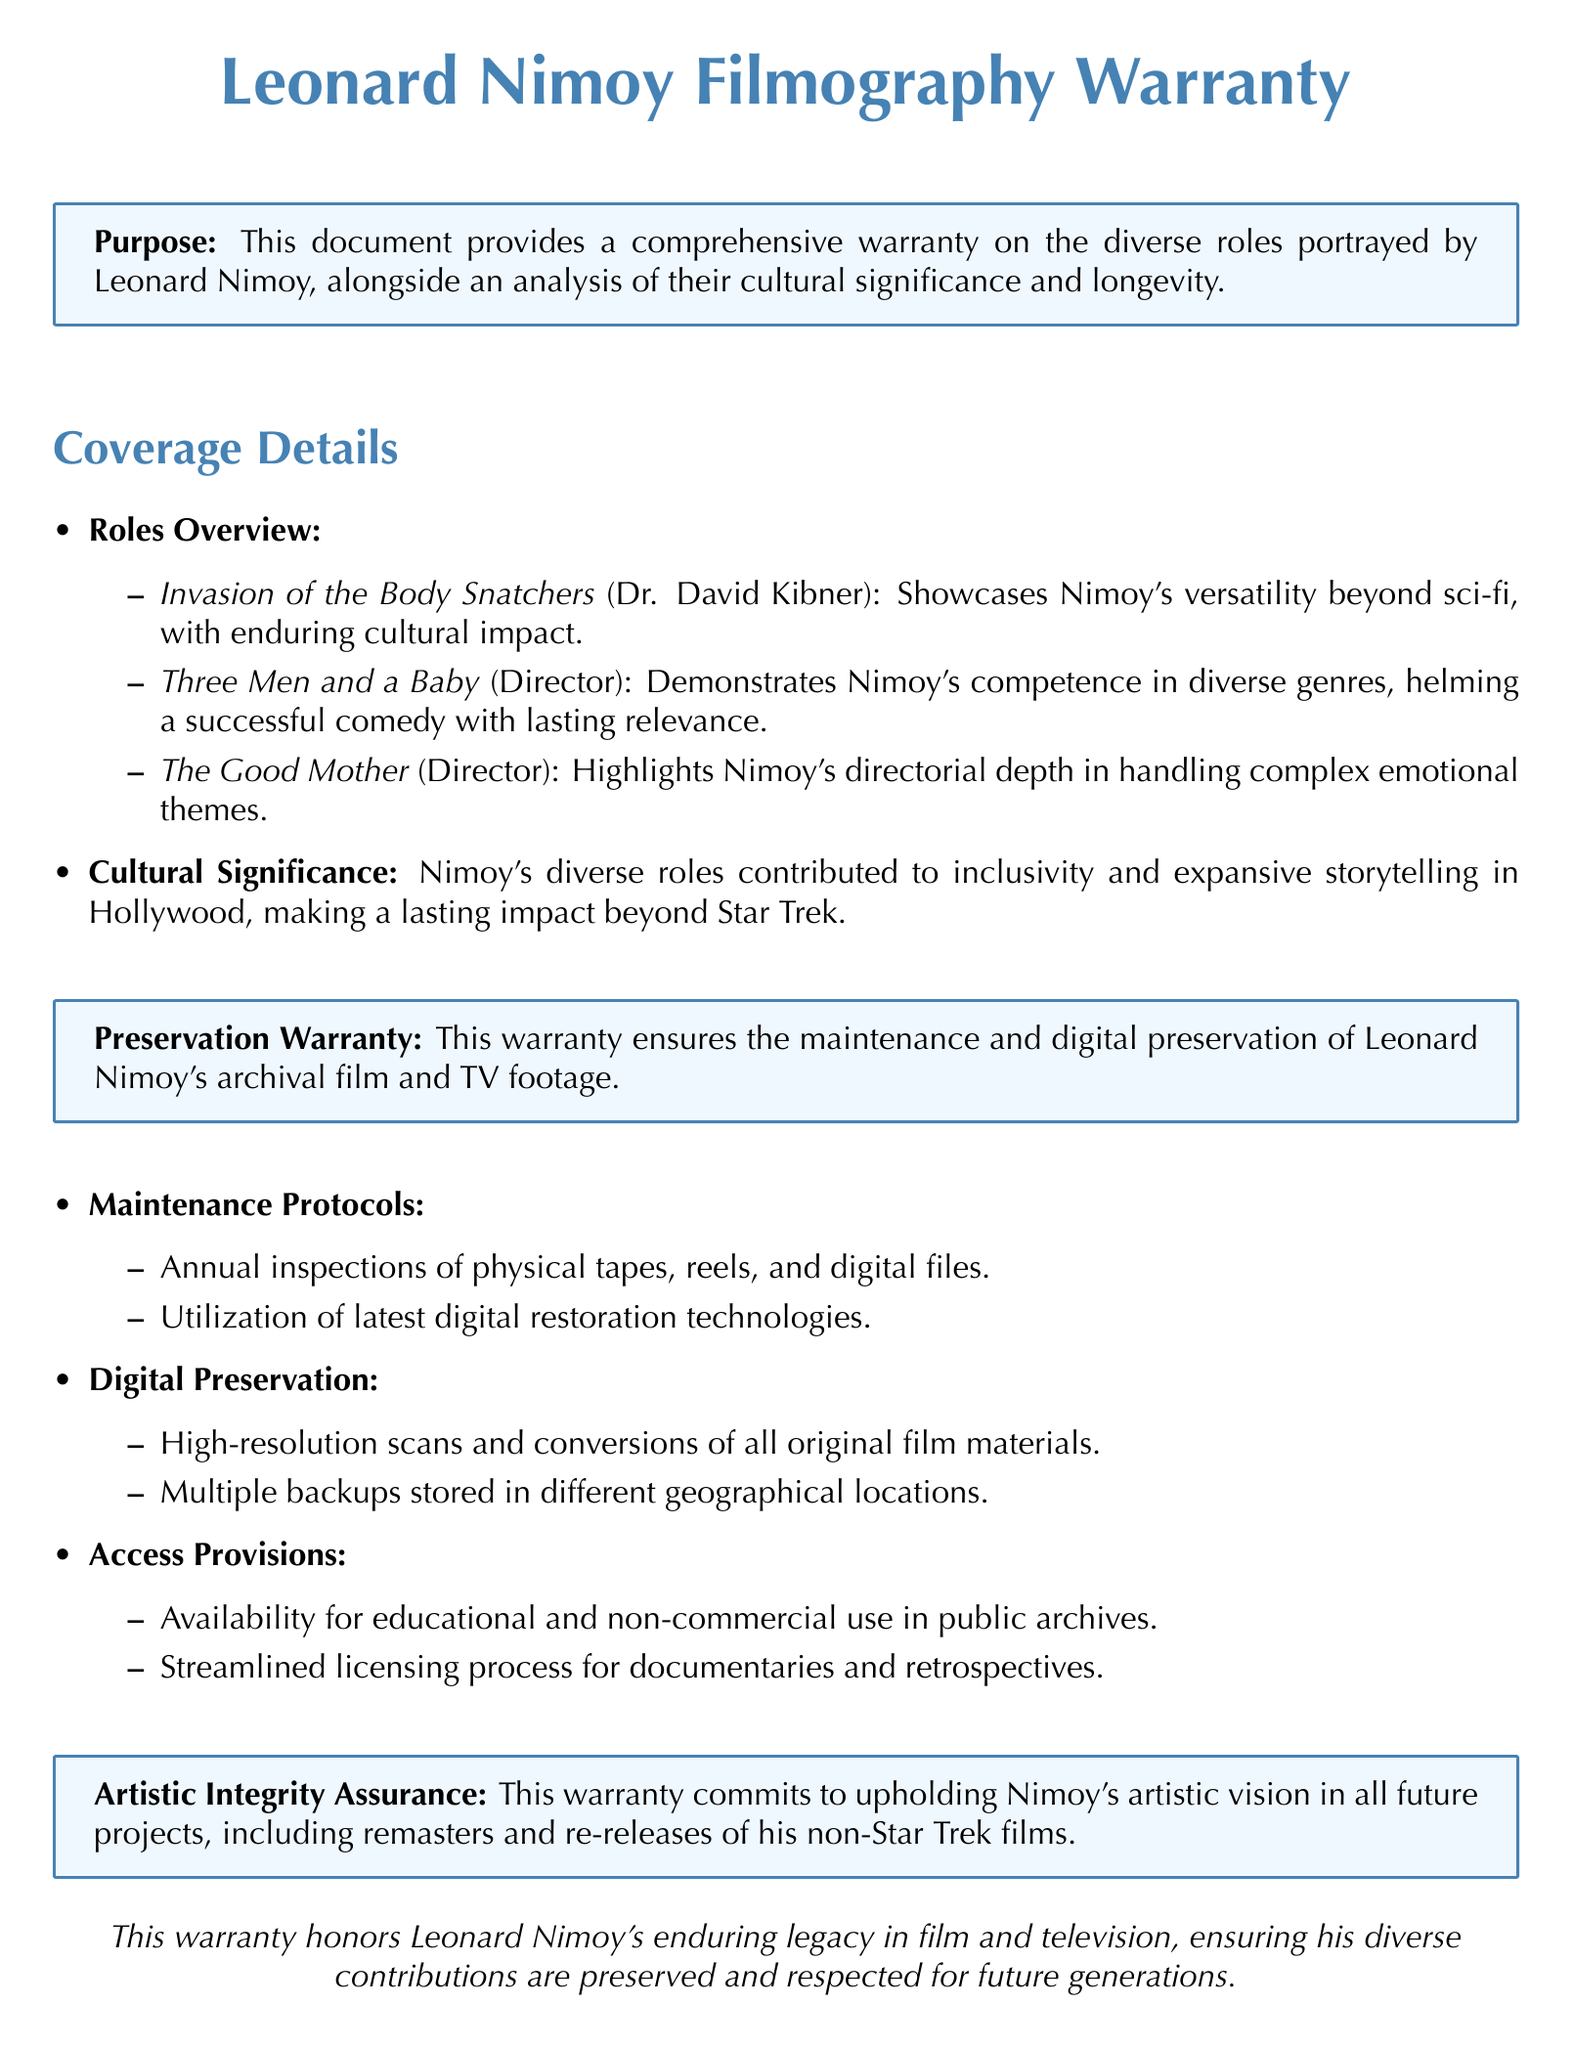What is the purpose of the warranty? The purpose is to provide a comprehensive warranty on the diverse roles portrayed by Leonard Nimoy, alongside an analysis of their cultural significance and longevity.
Answer: Comprehensive warranty on diverse roles Which character did Nimoy portray in "Invasion of the Body Snatchers"? The document states that Nimoy played Dr. David Kibner in the film.
Answer: Dr. David Kibner How many films are specifically mentioned under the roles overview? There are three films listed in the roles overview of the document.
Answer: Three What is the maintenance protocol for archival footage? The document outlines that annual inspections of physical tapes, reels, and digital files are conducted as part of the maintenance protocols.
Answer: Annual inspections What assurance does the warranty provide regarding Nimoy's artistic vision? The warranty commits to upholding Nimoy's artistic vision in all future projects.
Answer: Upholding artistic vision How many types of preservation measures are mentioned in the document? The document lists two types of preservation measures: maintenance protocols and digital preservation.
Answer: Two What does the warranty ensure about accessibility for archival footage? The warranty ensures availability for educational and non-commercial use in public archives.
Answer: Availability for educational use Who directed "Three Men and a Baby"? The document states that Leonard Nimoy directed the film.
Answer: Leonard Nimoy What is highlighted about Nimoy's contributions through his diverse roles? The document emphasizes that Nimoy's diverse roles contributed to inclusivity and expansive storytelling in Hollywood.
Answer: Inclusivity and expansive storytelling 